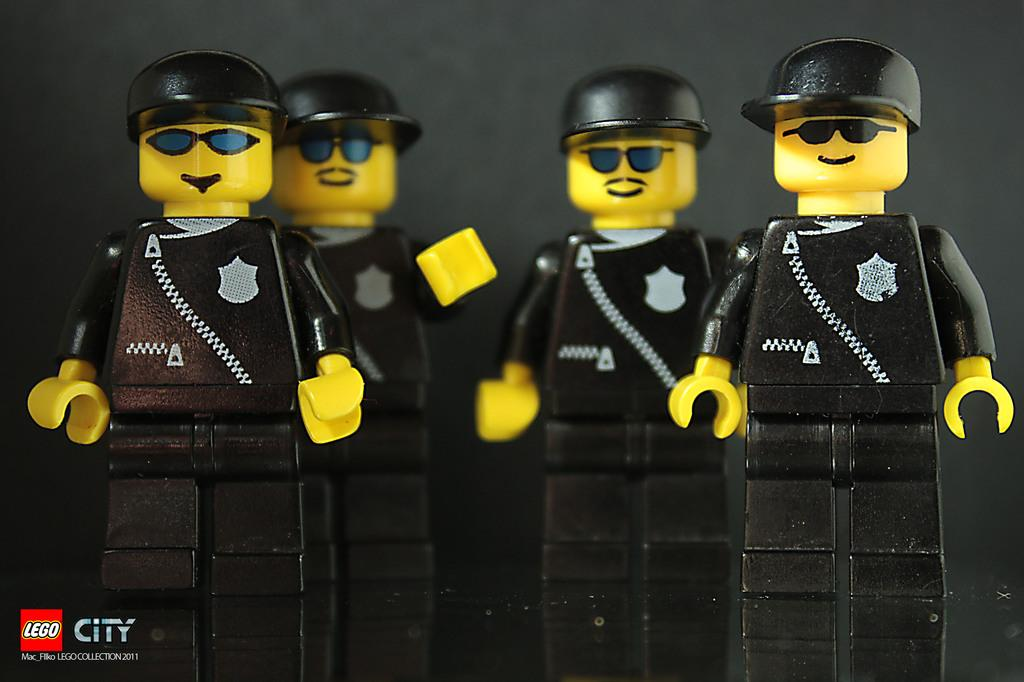What type of objects can be seen in the image? There are toys in the image. How many eyes can be seen on the toys in the image? There is no information about the number of eyes on the toys in the image, as the facts provided only mention that there are toys present. 